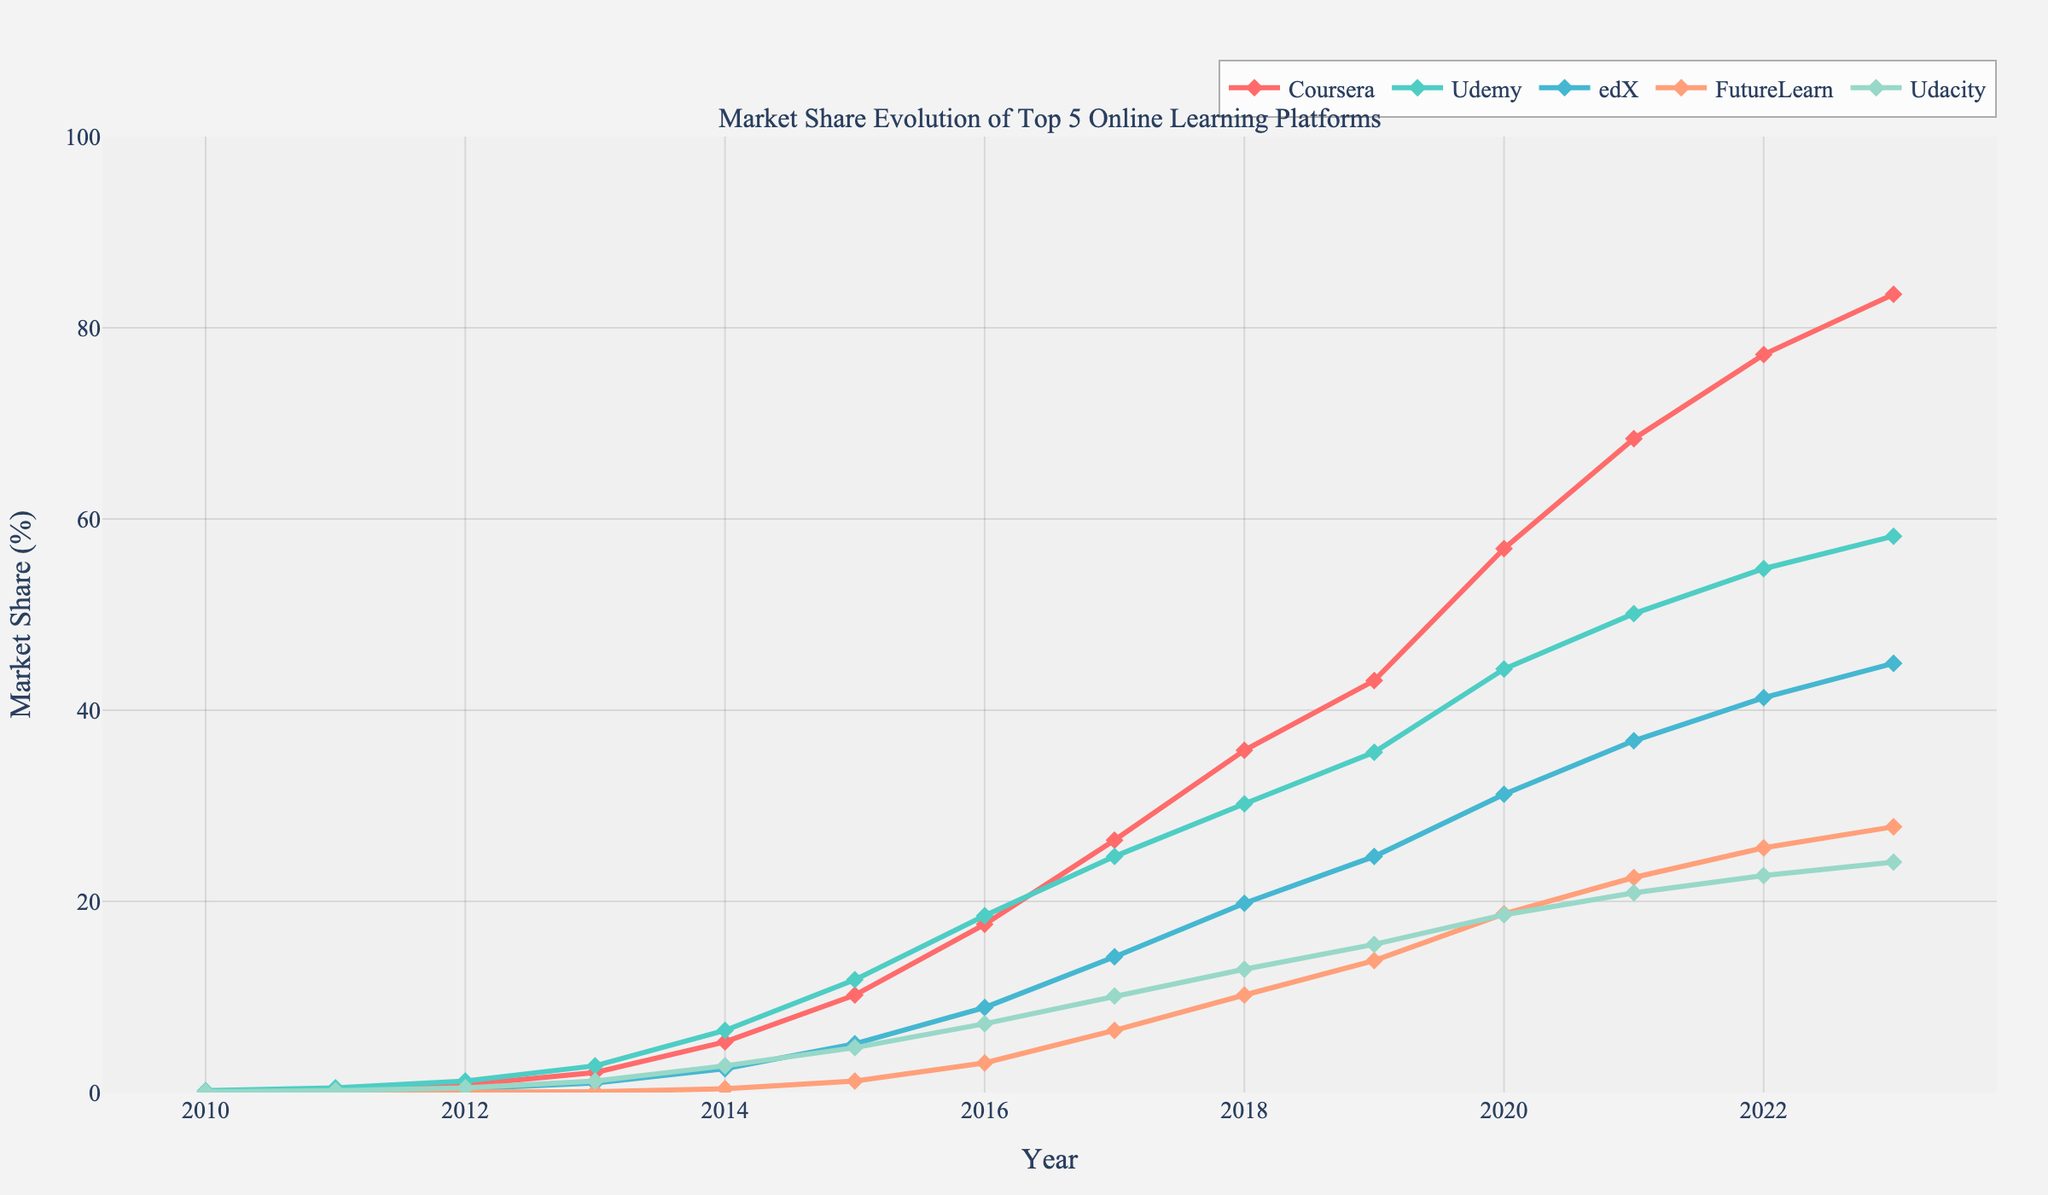What was the market share of Coursera in 2013? To find Coursera's market share in 2013, refer to the line representing Coursera and locate the point corresponding to the year 2013.
Answer: 2.1% Which platform had the highest market share in 2023? Compare the market shares of all platforms in 2023 by looking at the points for each platform in that year.
Answer: Coursera When did edX first achieve a market share of over 10%? Trace the line for edX and identify the year when its value first surpasses 10%.
Answer: 2017 What is the difference in market share between Udemy and FutureLearn in 2020? Find and subtract the market share of FutureLearn from Udemy for the year 2020 by examining their respective data points: Udemy (44.3) - FutureLearn (18.7).
Answer: 25.6% Between which years did Udacity see the most significant increase in market share? Identify the segment where Udacity's slope is the steepest by comparing the differences year-over-year. Increases: 2011 to 2012 (0.2 to 0.5), 2012 to 2013 (0.5 to 1.2), etc.
Answer: 2013 to 2014 How did Coursera's market share growth between 2015 and 2020 compare to that of Udemy? Calculate the growth for both platforms from 2015 to 2020: Coursera (56.9 - 10.2 = 46.7%), Udemy (44.3 - 11.8 = 32.5%), then compare.
Answer: Coursera had greater growth What is the average market share of FutureLearn from 2015 to 2020? Calculate the average by summing FutureLearn's market share from 2015 to 2020 (1.2, 3.1, 6.5, 10.2, 13.8, 18.7) and dividing by 6: (53.5/6).
Answer: 8.92% Which platform had the smallest market share increase from 2010 to 2023? Calculate the total increase for each platform over this period and find the smallest number.
Answer: FutureLearn What visual trend can you observe for Udemy's market share from 2017 to 2023? Observe the line for Udemy from 2017 onwards; it shows a steady rise but at a slower rate.
Answer: Steady increase How does the market share of edX in 2012 compare to Udacity in the same year? Compare the two points for edX and Udacity in the year 2012.
Answer: edX had higher market share 